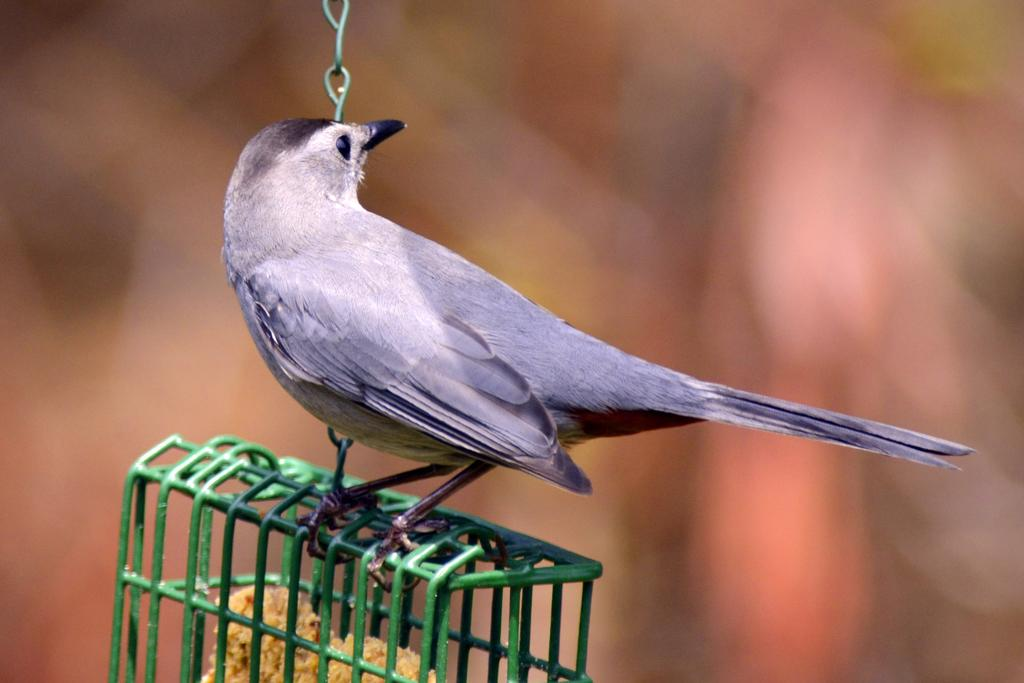What type of animal is in the image? There is a bird in the image. Where is the bird located in the image? The bird is in the center of the image. What is the bird resting on in the image? The bird is on a cage. What type of power does the bird have in the image? The bird does not have any power in the image; it is simply a bird resting on a cage. 